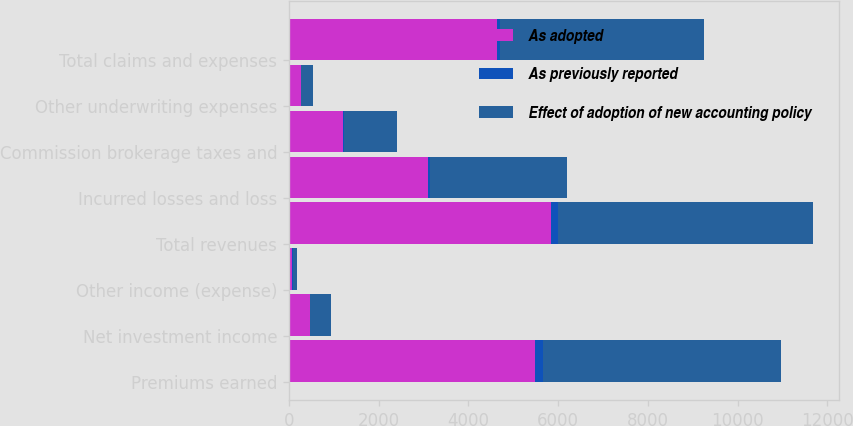Convert chart to OTSL. <chart><loc_0><loc_0><loc_500><loc_500><stacked_bar_chart><ecel><fcel>Premiums earned<fcel>Net investment income<fcel>Other income (expense)<fcel>Total revenues<fcel>Incurred losses and loss<fcel>Commission brokerage taxes and<fcel>Other underwriting expenses<fcel>Total claims and expenses<nl><fcel>As adopted<fcel>5481.5<fcel>473.8<fcel>60.4<fcel>5837.9<fcel>3101.9<fcel>1202<fcel>266<fcel>4629.4<nl><fcel>As previously reported<fcel>188.6<fcel>0.4<fcel>27.8<fcel>161.1<fcel>37.2<fcel>18.4<fcel>8.9<fcel>64.5<nl><fcel>Effect of adoption of new accounting policy<fcel>5292.8<fcel>473.5<fcel>88.3<fcel>5676.8<fcel>3064.7<fcel>1183.6<fcel>257.1<fcel>4564.9<nl></chart> 